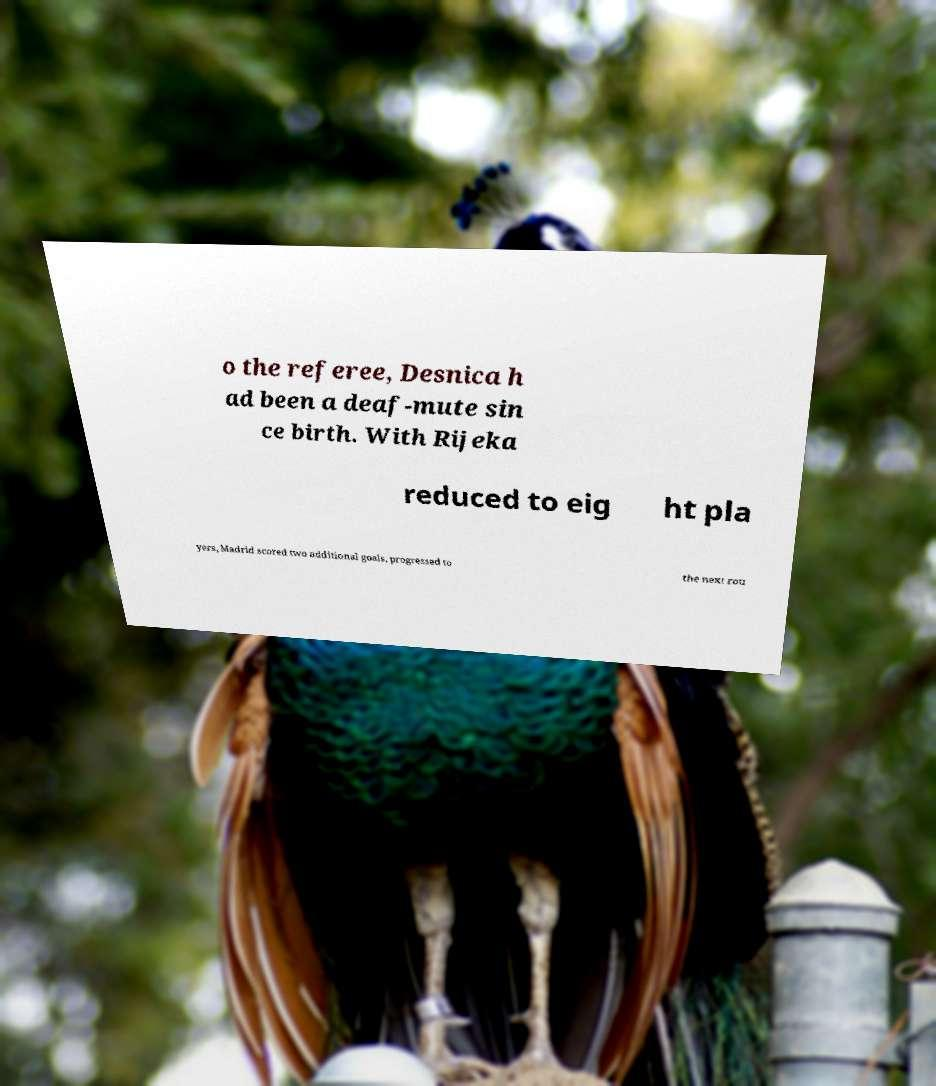Could you extract and type out the text from this image? o the referee, Desnica h ad been a deaf-mute sin ce birth. With Rijeka reduced to eig ht pla yers, Madrid scored two additional goals, progressed to the next rou 